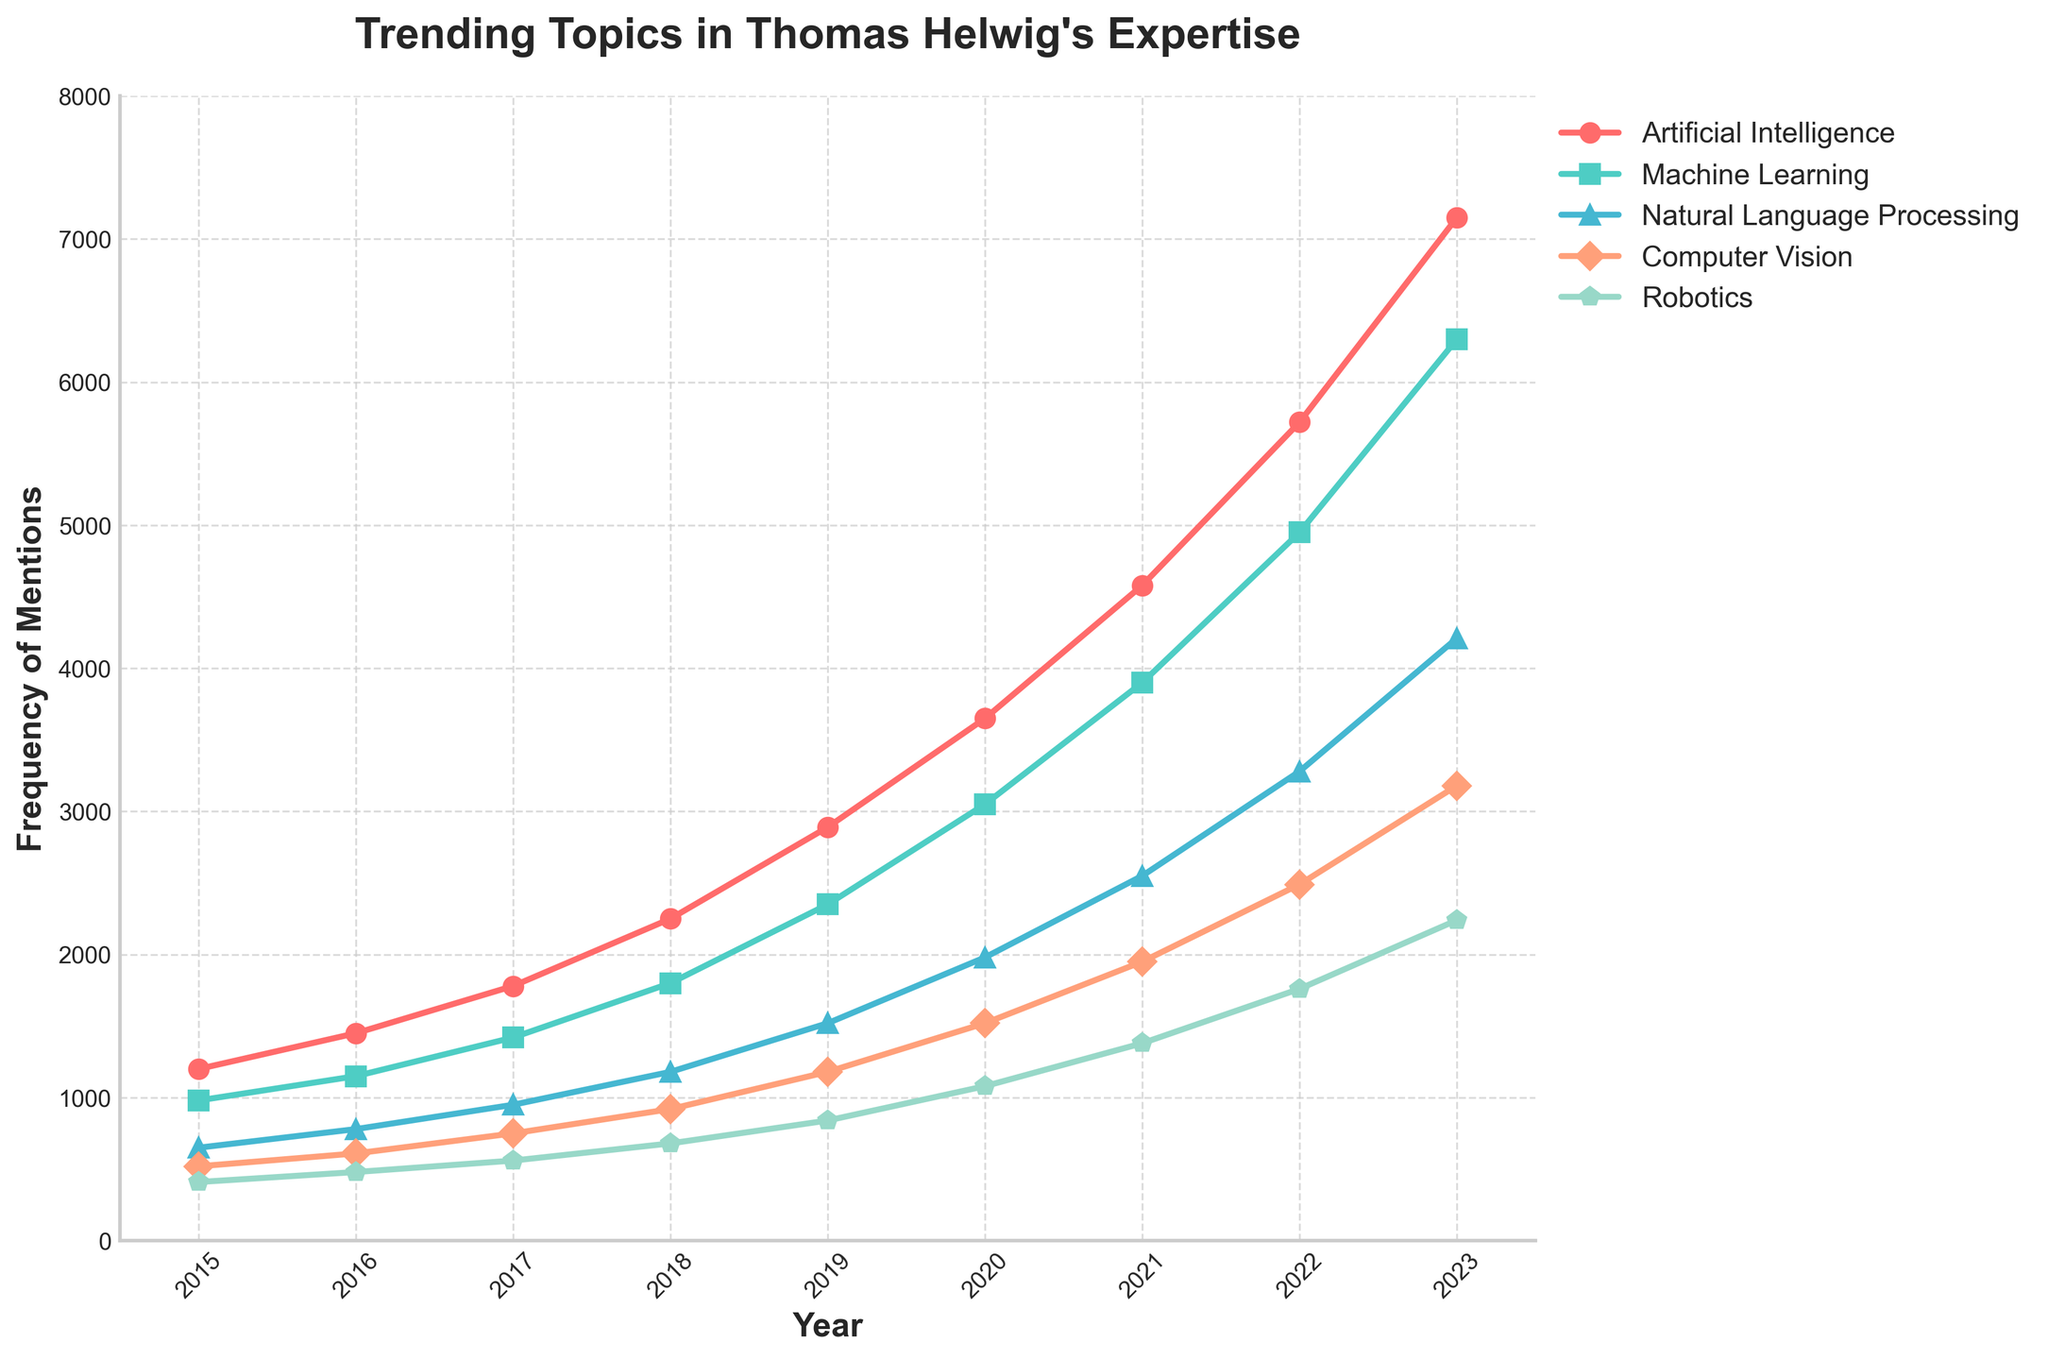Which topic had the highest frequency of mentions in 2023? The graph shows that Artificial Intelligence had the highest frequency of mentions in 2023.
Answer: Artificial Intelligence Which topic showed the steepest increase in mentions between 2015 and 2023? By looking at the slopes of the lines from 2015 to 2023, Artificial Intelligence had the steepest increase.
Answer: Artificial Intelligence By how much did the mentions of Machine Learning increase from 2015 to 2023? In 2015, Machine Learning had 980 mentions. By 2023, it had 6300 mentions. The increase is 6300 - 980 = 5320.
Answer: 5320 Which two topics had the closest number of mentions in the year 2016? In 2016, Machine Learning had 1150 mentions, and Natural Language Processing had 780. However, Computer Vision had 610 mentions, which is closer to Natural Language Processing's 780.
Answer: NLP and CV What is the average number of mentions for Robotics between 2015 and 2023? Summing the mentions from 2015 to 2023: 410 + 480 + 560 + 680 + 840 + 1080 + 1380 + 1760 + 2240 = 9430. Divide by the number of years (9): 9430 / 9 ≈ 1047.8.
Answer: 1047.8 Compare the trends of Natural Language Processing and Computer Vision between 2015 and 2023. Which one had more consistent growth? Both trends show growth, but Computer Vision had a smoother and more consistent increase, while Natural Language Processing had more rapid growth especially after 2020.
Answer: Computer Vision In which year did mentions of Artificial Intelligence surpass 4000? The graph shows that Artificial Intelligence surpassed 4000 mentions in 2021.
Answer: 2021 Between 2019 and 2023, which topic had the largest increase in mentions? By comparing the differences from 2019 to 2023: AI increased by 4260, ML by 3950, NLP by 2690, CV by 2000, and Robotics by 1400. Artificial Intelligence had the largest increase.
Answer: Artificial Intelligence In 2020, which topic had the lowest number of mentions, and what was that number? The graph shows Robotics had the lowest number of mentions in 2020, with 1080 mentions.
Answer: Robotics, 1080 What is the combined number of mentions for Artificial Intelligence and Machine Learning in 2022? In 2022, AI had 5720 mentions and ML had 4950 mentions. Combined: 5720 + 4950 = 10670.
Answer: 10670 